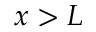<formula> <loc_0><loc_0><loc_500><loc_500>x > L</formula> 